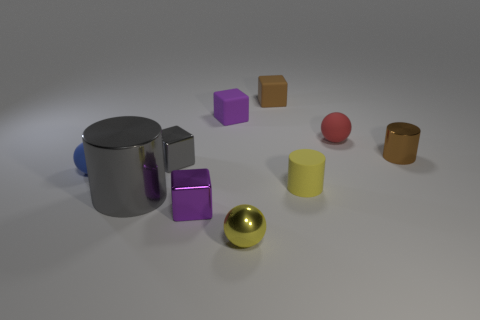Subtract all cylinders. How many objects are left? 7 Subtract 0 blue blocks. How many objects are left? 10 Subtract all small blue matte things. Subtract all big brown matte spheres. How many objects are left? 9 Add 7 tiny brown rubber cubes. How many tiny brown rubber cubes are left? 8 Add 6 gray shiny cylinders. How many gray shiny cylinders exist? 7 